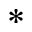<formula> <loc_0><loc_0><loc_500><loc_500>*</formula> 